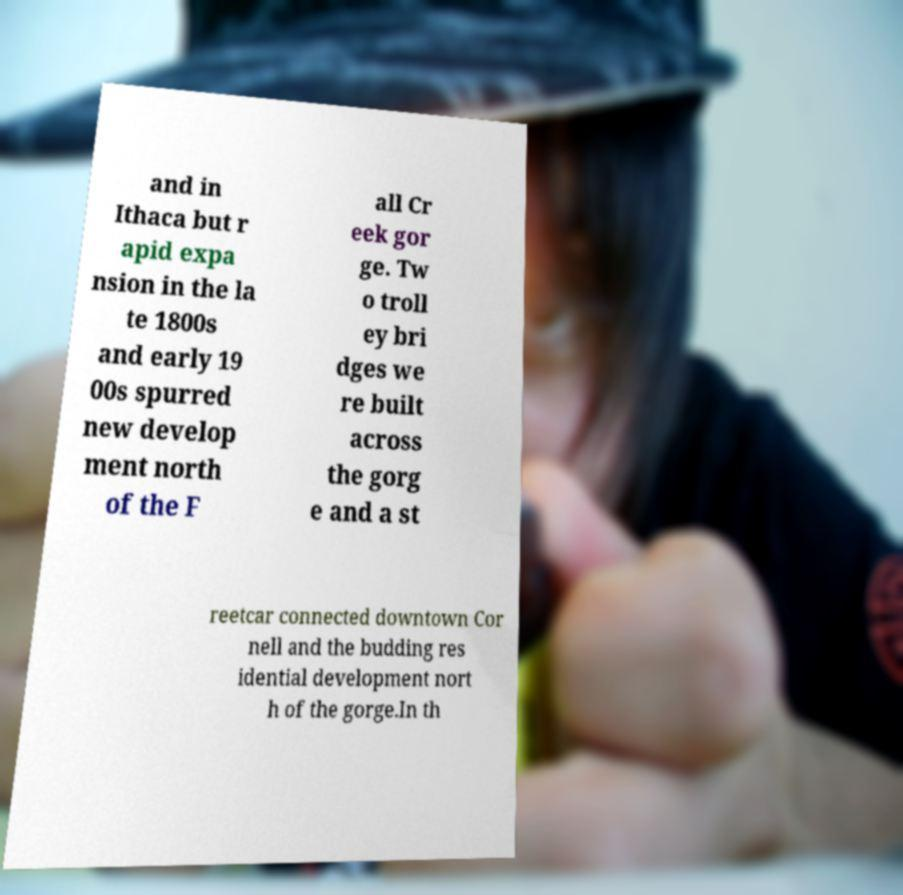I need the written content from this picture converted into text. Can you do that? and in Ithaca but r apid expa nsion in the la te 1800s and early 19 00s spurred new develop ment north of the F all Cr eek gor ge. Tw o troll ey bri dges we re built across the gorg e and a st reetcar connected downtown Cor nell and the budding res idential development nort h of the gorge.In th 